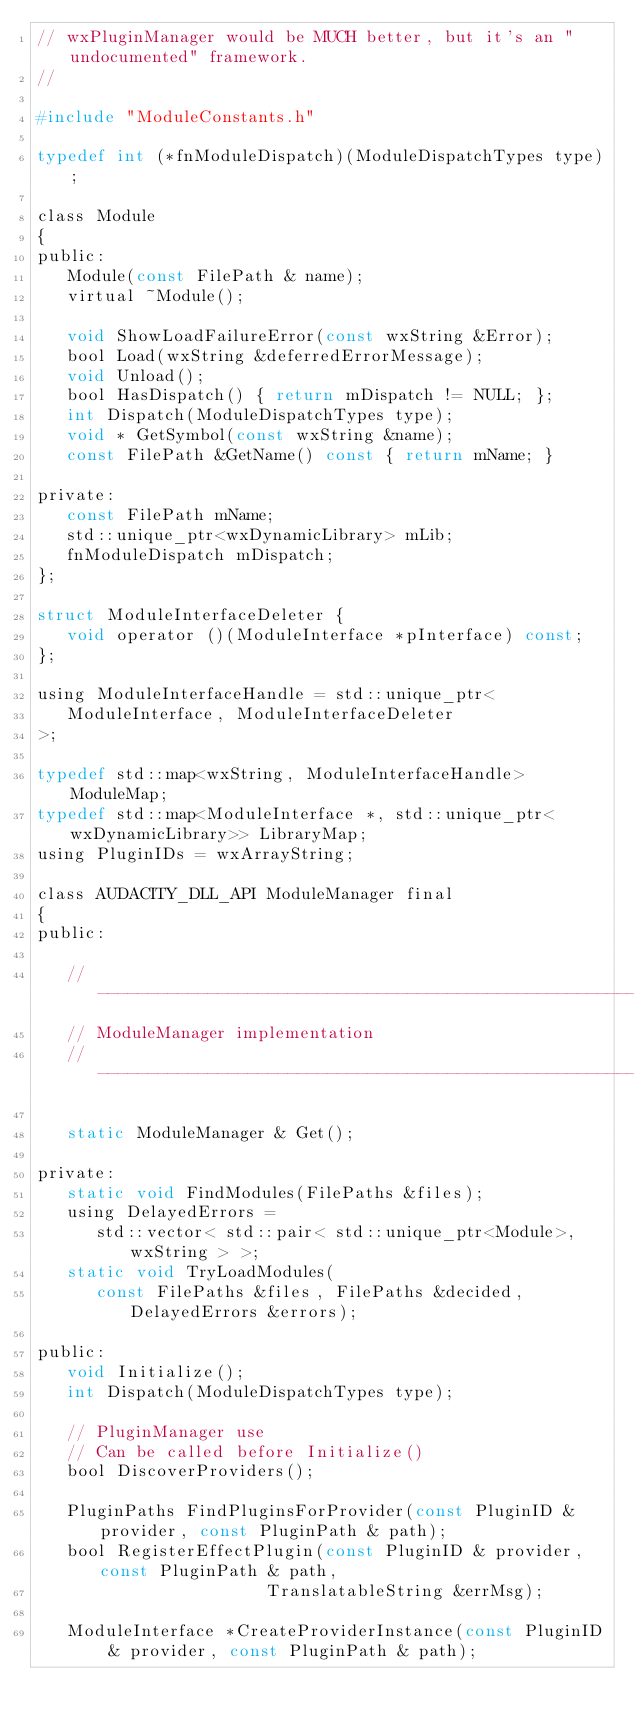Convert code to text. <code><loc_0><loc_0><loc_500><loc_500><_C_>// wxPluginManager would be MUCH better, but it's an "undocumented" framework.
//

#include "ModuleConstants.h"

typedef int (*fnModuleDispatch)(ModuleDispatchTypes type);

class Module
{
public:
   Module(const FilePath & name);
   virtual ~Module();

   void ShowLoadFailureError(const wxString &Error);
   bool Load(wxString &deferredErrorMessage);
   void Unload();
   bool HasDispatch() { return mDispatch != NULL; };
   int Dispatch(ModuleDispatchTypes type);
   void * GetSymbol(const wxString &name);
   const FilePath &GetName() const { return mName; }

private:
   const FilePath mName;
   std::unique_ptr<wxDynamicLibrary> mLib;
   fnModuleDispatch mDispatch;
};

struct ModuleInterfaceDeleter {
   void operator ()(ModuleInterface *pInterface) const;
};

using ModuleInterfaceHandle = std::unique_ptr<
   ModuleInterface, ModuleInterfaceDeleter
>;

typedef std::map<wxString, ModuleInterfaceHandle> ModuleMap;
typedef std::map<ModuleInterface *, std::unique_ptr<wxDynamicLibrary>> LibraryMap;
using PluginIDs = wxArrayString;

class AUDACITY_DLL_API ModuleManager final
{
public:

   // -------------------------------------------------------------------------
   // ModuleManager implementation
   // -------------------------------------------------------------------------

   static ModuleManager & Get();
   
private:
   static void FindModules(FilePaths &files);
   using DelayedErrors =
      std::vector< std::pair< std::unique_ptr<Module>, wxString > >;
   static void TryLoadModules(
      const FilePaths &files, FilePaths &decided, DelayedErrors &errors);

public:
   void Initialize();
   int Dispatch(ModuleDispatchTypes type);

   // PluginManager use
   // Can be called before Initialize()
   bool DiscoverProviders();

   PluginPaths FindPluginsForProvider(const PluginID & provider, const PluginPath & path);
   bool RegisterEffectPlugin(const PluginID & provider, const PluginPath & path,
                       TranslatableString &errMsg);

   ModuleInterface *CreateProviderInstance(const PluginID & provider, const PluginPath & path);</code> 